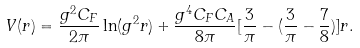<formula> <loc_0><loc_0><loc_500><loc_500>V ( r ) = \frac { g ^ { 2 } C _ { F } } { 2 \pi } \ln ( g ^ { 2 } r ) + \frac { g ^ { 4 } C _ { F } C _ { A } } { 8 \pi } [ \frac { 3 } { \pi } - ( \frac { 3 } { \pi } - \frac { 7 } { 8 } ) ] r .</formula> 